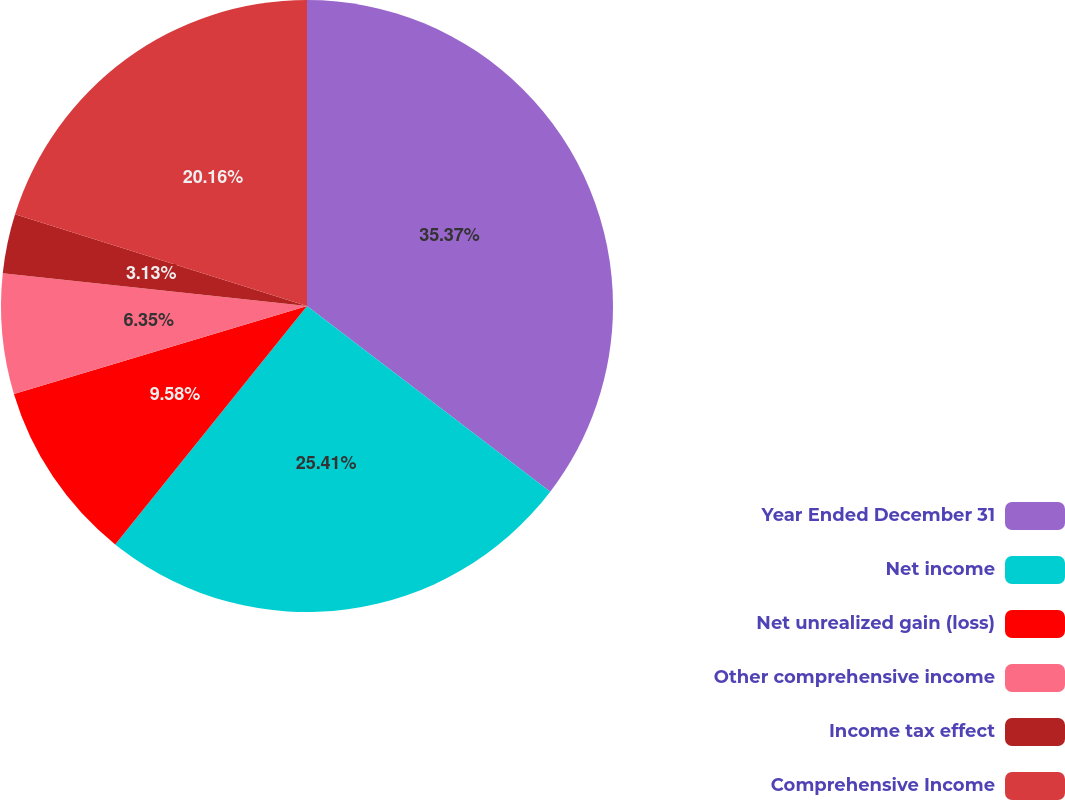<chart> <loc_0><loc_0><loc_500><loc_500><pie_chart><fcel>Year Ended December 31<fcel>Net income<fcel>Net unrealized gain (loss)<fcel>Other comprehensive income<fcel>Income tax effect<fcel>Comprehensive Income<nl><fcel>35.38%<fcel>25.41%<fcel>9.58%<fcel>6.35%<fcel>3.13%<fcel>20.16%<nl></chart> 